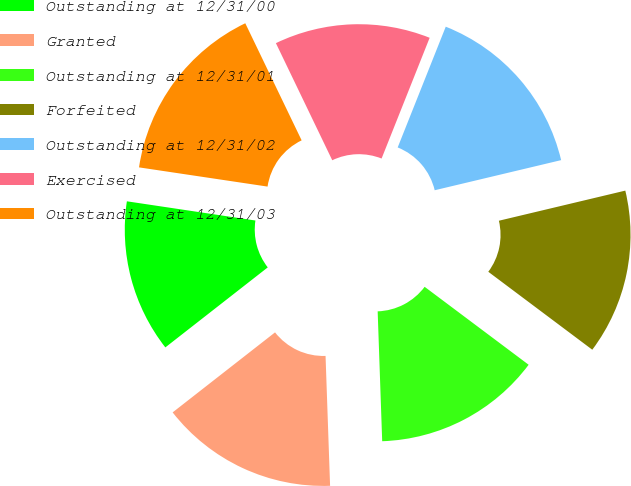<chart> <loc_0><loc_0><loc_500><loc_500><pie_chart><fcel>Outstanding at 12/31/00<fcel>Granted<fcel>Outstanding at 12/31/01<fcel>Forfeited<fcel>Outstanding at 12/31/02<fcel>Exercised<fcel>Outstanding at 12/31/03<nl><fcel>12.92%<fcel>15.0%<fcel>14.21%<fcel>13.96%<fcel>15.25%<fcel>13.17%<fcel>15.5%<nl></chart> 